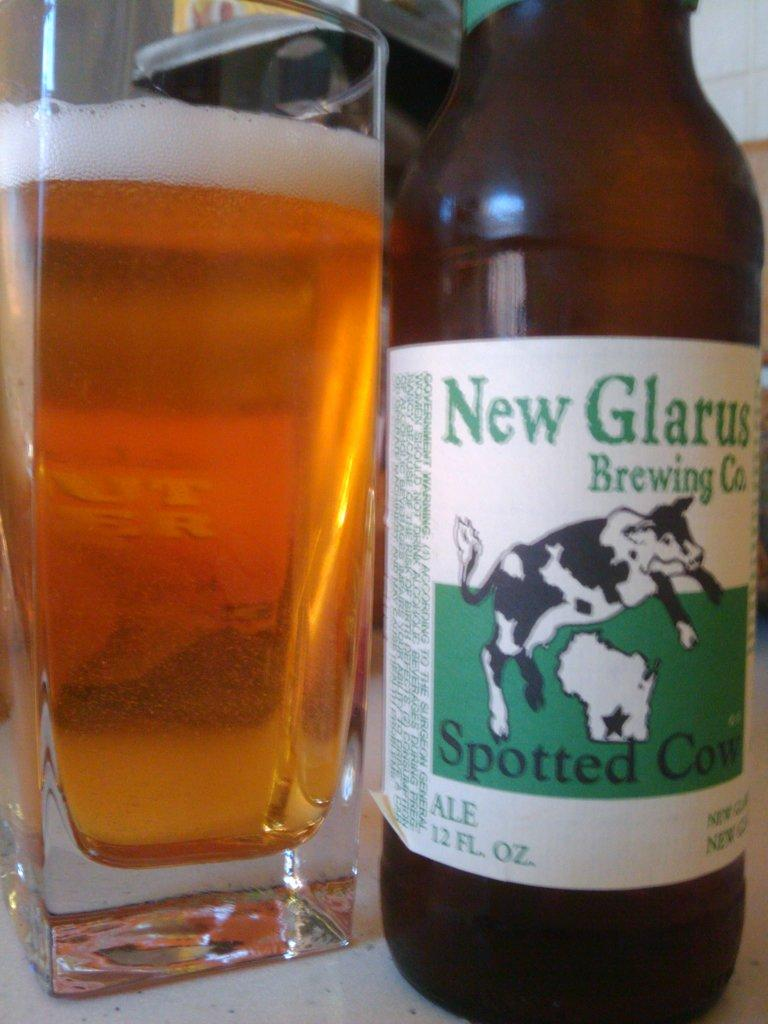<image>
Present a compact description of the photo's key features. A bottle of New Glarus Spotted Cow beer. 